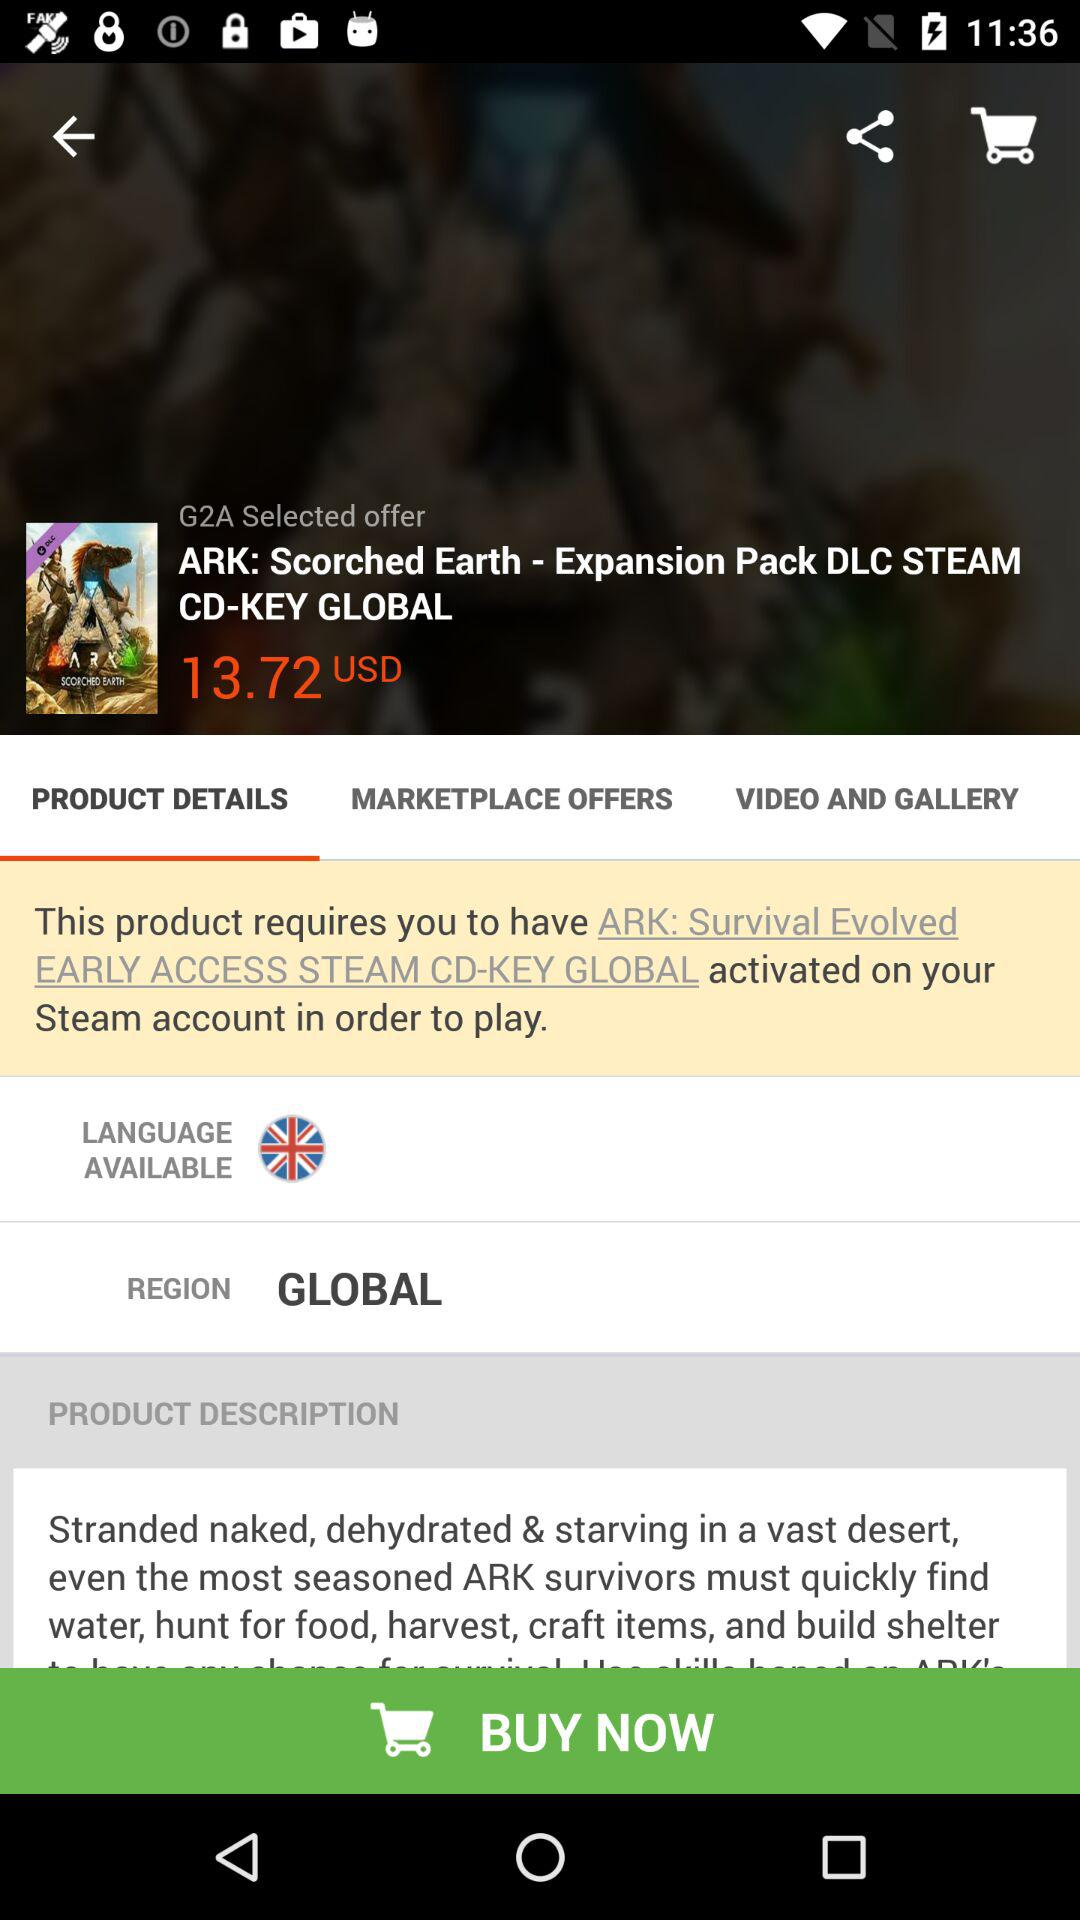How many different currencies are available?
Answer the question using a single word or phrase. 1 